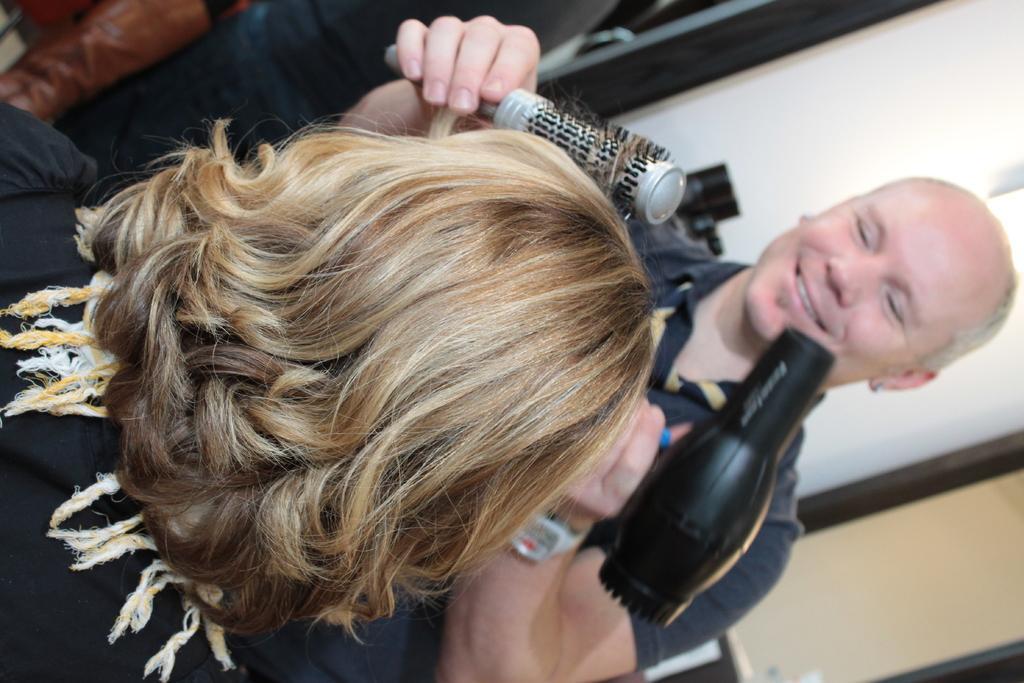Please provide a concise description of this image. This picture is in rightward direction. Towards the right, there is a man holding a brush and a hair dryer. Towards the left, there is a woman. 